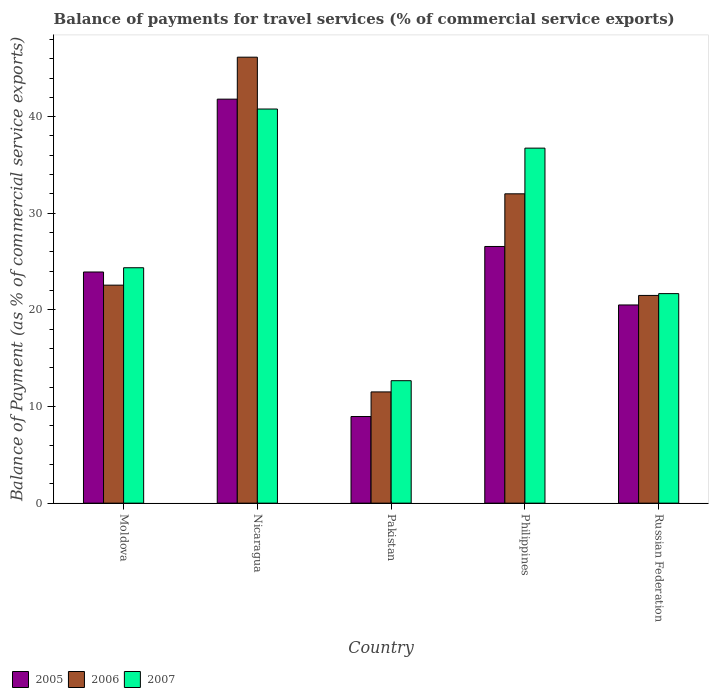How many different coloured bars are there?
Your answer should be compact. 3. How many groups of bars are there?
Make the answer very short. 5. Are the number of bars per tick equal to the number of legend labels?
Keep it short and to the point. Yes. Are the number of bars on each tick of the X-axis equal?
Give a very brief answer. Yes. How many bars are there on the 5th tick from the right?
Give a very brief answer. 3. What is the label of the 1st group of bars from the left?
Make the answer very short. Moldova. In how many cases, is the number of bars for a given country not equal to the number of legend labels?
Offer a very short reply. 0. What is the balance of payments for travel services in 2005 in Nicaragua?
Provide a short and direct response. 41.81. Across all countries, what is the maximum balance of payments for travel services in 2005?
Give a very brief answer. 41.81. Across all countries, what is the minimum balance of payments for travel services in 2007?
Your response must be concise. 12.67. In which country was the balance of payments for travel services in 2005 maximum?
Offer a terse response. Nicaragua. What is the total balance of payments for travel services in 2006 in the graph?
Offer a very short reply. 133.74. What is the difference between the balance of payments for travel services in 2005 in Moldova and that in Philippines?
Give a very brief answer. -2.64. What is the difference between the balance of payments for travel services in 2006 in Russian Federation and the balance of payments for travel services in 2005 in Moldova?
Provide a succinct answer. -2.43. What is the average balance of payments for travel services in 2005 per country?
Ensure brevity in your answer.  24.36. What is the difference between the balance of payments for travel services of/in 2005 and balance of payments for travel services of/in 2006 in Russian Federation?
Keep it short and to the point. -0.99. What is the ratio of the balance of payments for travel services in 2007 in Nicaragua to that in Philippines?
Give a very brief answer. 1.11. Is the balance of payments for travel services in 2006 in Nicaragua less than that in Pakistan?
Your response must be concise. No. Is the difference between the balance of payments for travel services in 2005 in Moldova and Pakistan greater than the difference between the balance of payments for travel services in 2006 in Moldova and Pakistan?
Provide a short and direct response. Yes. What is the difference between the highest and the second highest balance of payments for travel services in 2007?
Give a very brief answer. 16.43. What is the difference between the highest and the lowest balance of payments for travel services in 2005?
Offer a very short reply. 32.85. In how many countries, is the balance of payments for travel services in 2007 greater than the average balance of payments for travel services in 2007 taken over all countries?
Your answer should be compact. 2. Is the sum of the balance of payments for travel services in 2005 in Nicaragua and Russian Federation greater than the maximum balance of payments for travel services in 2006 across all countries?
Ensure brevity in your answer.  Yes. What does the 1st bar from the right in Russian Federation represents?
Offer a terse response. 2007. Is it the case that in every country, the sum of the balance of payments for travel services in 2007 and balance of payments for travel services in 2005 is greater than the balance of payments for travel services in 2006?
Give a very brief answer. Yes. How many countries are there in the graph?
Provide a short and direct response. 5. What is the difference between two consecutive major ticks on the Y-axis?
Ensure brevity in your answer.  10. Does the graph contain grids?
Give a very brief answer. No. What is the title of the graph?
Give a very brief answer. Balance of payments for travel services (% of commercial service exports). What is the label or title of the X-axis?
Ensure brevity in your answer.  Country. What is the label or title of the Y-axis?
Ensure brevity in your answer.  Balance of Payment (as % of commercial service exports). What is the Balance of Payment (as % of commercial service exports) in 2005 in Moldova?
Your answer should be very brief. 23.92. What is the Balance of Payment (as % of commercial service exports) in 2006 in Moldova?
Provide a short and direct response. 22.56. What is the Balance of Payment (as % of commercial service exports) in 2007 in Moldova?
Offer a terse response. 24.36. What is the Balance of Payment (as % of commercial service exports) in 2005 in Nicaragua?
Offer a very short reply. 41.81. What is the Balance of Payment (as % of commercial service exports) of 2006 in Nicaragua?
Your answer should be compact. 46.16. What is the Balance of Payment (as % of commercial service exports) in 2007 in Nicaragua?
Your answer should be very brief. 40.79. What is the Balance of Payment (as % of commercial service exports) in 2005 in Pakistan?
Your response must be concise. 8.97. What is the Balance of Payment (as % of commercial service exports) in 2006 in Pakistan?
Give a very brief answer. 11.51. What is the Balance of Payment (as % of commercial service exports) of 2007 in Pakistan?
Provide a short and direct response. 12.67. What is the Balance of Payment (as % of commercial service exports) in 2005 in Philippines?
Your response must be concise. 26.56. What is the Balance of Payment (as % of commercial service exports) of 2006 in Philippines?
Make the answer very short. 32.02. What is the Balance of Payment (as % of commercial service exports) in 2007 in Philippines?
Make the answer very short. 36.74. What is the Balance of Payment (as % of commercial service exports) of 2005 in Russian Federation?
Ensure brevity in your answer.  20.51. What is the Balance of Payment (as % of commercial service exports) in 2006 in Russian Federation?
Your answer should be very brief. 21.5. What is the Balance of Payment (as % of commercial service exports) in 2007 in Russian Federation?
Provide a short and direct response. 21.69. Across all countries, what is the maximum Balance of Payment (as % of commercial service exports) of 2005?
Give a very brief answer. 41.81. Across all countries, what is the maximum Balance of Payment (as % of commercial service exports) in 2006?
Ensure brevity in your answer.  46.16. Across all countries, what is the maximum Balance of Payment (as % of commercial service exports) of 2007?
Your answer should be very brief. 40.79. Across all countries, what is the minimum Balance of Payment (as % of commercial service exports) in 2005?
Your answer should be very brief. 8.97. Across all countries, what is the minimum Balance of Payment (as % of commercial service exports) in 2006?
Offer a very short reply. 11.51. Across all countries, what is the minimum Balance of Payment (as % of commercial service exports) in 2007?
Keep it short and to the point. 12.67. What is the total Balance of Payment (as % of commercial service exports) of 2005 in the graph?
Make the answer very short. 121.78. What is the total Balance of Payment (as % of commercial service exports) in 2006 in the graph?
Your answer should be compact. 133.74. What is the total Balance of Payment (as % of commercial service exports) in 2007 in the graph?
Make the answer very short. 136.26. What is the difference between the Balance of Payment (as % of commercial service exports) of 2005 in Moldova and that in Nicaragua?
Make the answer very short. -17.89. What is the difference between the Balance of Payment (as % of commercial service exports) in 2006 in Moldova and that in Nicaragua?
Your answer should be very brief. -23.59. What is the difference between the Balance of Payment (as % of commercial service exports) of 2007 in Moldova and that in Nicaragua?
Keep it short and to the point. -16.43. What is the difference between the Balance of Payment (as % of commercial service exports) of 2005 in Moldova and that in Pakistan?
Your answer should be very brief. 14.96. What is the difference between the Balance of Payment (as % of commercial service exports) in 2006 in Moldova and that in Pakistan?
Provide a succinct answer. 11.05. What is the difference between the Balance of Payment (as % of commercial service exports) of 2007 in Moldova and that in Pakistan?
Keep it short and to the point. 11.69. What is the difference between the Balance of Payment (as % of commercial service exports) in 2005 in Moldova and that in Philippines?
Your answer should be very brief. -2.64. What is the difference between the Balance of Payment (as % of commercial service exports) of 2006 in Moldova and that in Philippines?
Your answer should be very brief. -9.45. What is the difference between the Balance of Payment (as % of commercial service exports) of 2007 in Moldova and that in Philippines?
Provide a succinct answer. -12.38. What is the difference between the Balance of Payment (as % of commercial service exports) of 2005 in Moldova and that in Russian Federation?
Keep it short and to the point. 3.41. What is the difference between the Balance of Payment (as % of commercial service exports) of 2006 in Moldova and that in Russian Federation?
Make the answer very short. 1.06. What is the difference between the Balance of Payment (as % of commercial service exports) in 2007 in Moldova and that in Russian Federation?
Keep it short and to the point. 2.68. What is the difference between the Balance of Payment (as % of commercial service exports) in 2005 in Nicaragua and that in Pakistan?
Offer a terse response. 32.85. What is the difference between the Balance of Payment (as % of commercial service exports) in 2006 in Nicaragua and that in Pakistan?
Make the answer very short. 34.64. What is the difference between the Balance of Payment (as % of commercial service exports) in 2007 in Nicaragua and that in Pakistan?
Your answer should be very brief. 28.12. What is the difference between the Balance of Payment (as % of commercial service exports) in 2005 in Nicaragua and that in Philippines?
Offer a terse response. 15.25. What is the difference between the Balance of Payment (as % of commercial service exports) of 2006 in Nicaragua and that in Philippines?
Provide a short and direct response. 14.14. What is the difference between the Balance of Payment (as % of commercial service exports) of 2007 in Nicaragua and that in Philippines?
Ensure brevity in your answer.  4.05. What is the difference between the Balance of Payment (as % of commercial service exports) in 2005 in Nicaragua and that in Russian Federation?
Keep it short and to the point. 21.3. What is the difference between the Balance of Payment (as % of commercial service exports) in 2006 in Nicaragua and that in Russian Federation?
Ensure brevity in your answer.  24.66. What is the difference between the Balance of Payment (as % of commercial service exports) in 2007 in Nicaragua and that in Russian Federation?
Your answer should be compact. 19.1. What is the difference between the Balance of Payment (as % of commercial service exports) of 2005 in Pakistan and that in Philippines?
Keep it short and to the point. -17.6. What is the difference between the Balance of Payment (as % of commercial service exports) of 2006 in Pakistan and that in Philippines?
Provide a short and direct response. -20.5. What is the difference between the Balance of Payment (as % of commercial service exports) in 2007 in Pakistan and that in Philippines?
Keep it short and to the point. -24.07. What is the difference between the Balance of Payment (as % of commercial service exports) of 2005 in Pakistan and that in Russian Federation?
Offer a terse response. -11.55. What is the difference between the Balance of Payment (as % of commercial service exports) of 2006 in Pakistan and that in Russian Federation?
Your response must be concise. -9.98. What is the difference between the Balance of Payment (as % of commercial service exports) in 2007 in Pakistan and that in Russian Federation?
Your response must be concise. -9.01. What is the difference between the Balance of Payment (as % of commercial service exports) in 2005 in Philippines and that in Russian Federation?
Make the answer very short. 6.05. What is the difference between the Balance of Payment (as % of commercial service exports) in 2006 in Philippines and that in Russian Federation?
Keep it short and to the point. 10.52. What is the difference between the Balance of Payment (as % of commercial service exports) in 2007 in Philippines and that in Russian Federation?
Keep it short and to the point. 15.06. What is the difference between the Balance of Payment (as % of commercial service exports) in 2005 in Moldova and the Balance of Payment (as % of commercial service exports) in 2006 in Nicaragua?
Offer a terse response. -22.23. What is the difference between the Balance of Payment (as % of commercial service exports) in 2005 in Moldova and the Balance of Payment (as % of commercial service exports) in 2007 in Nicaragua?
Provide a succinct answer. -16.87. What is the difference between the Balance of Payment (as % of commercial service exports) in 2006 in Moldova and the Balance of Payment (as % of commercial service exports) in 2007 in Nicaragua?
Keep it short and to the point. -18.23. What is the difference between the Balance of Payment (as % of commercial service exports) in 2005 in Moldova and the Balance of Payment (as % of commercial service exports) in 2006 in Pakistan?
Offer a very short reply. 12.41. What is the difference between the Balance of Payment (as % of commercial service exports) in 2005 in Moldova and the Balance of Payment (as % of commercial service exports) in 2007 in Pakistan?
Your answer should be compact. 11.25. What is the difference between the Balance of Payment (as % of commercial service exports) of 2006 in Moldova and the Balance of Payment (as % of commercial service exports) of 2007 in Pakistan?
Your answer should be very brief. 9.89. What is the difference between the Balance of Payment (as % of commercial service exports) in 2005 in Moldova and the Balance of Payment (as % of commercial service exports) in 2006 in Philippines?
Your answer should be compact. -8.09. What is the difference between the Balance of Payment (as % of commercial service exports) of 2005 in Moldova and the Balance of Payment (as % of commercial service exports) of 2007 in Philippines?
Make the answer very short. -12.82. What is the difference between the Balance of Payment (as % of commercial service exports) in 2006 in Moldova and the Balance of Payment (as % of commercial service exports) in 2007 in Philippines?
Your response must be concise. -14.18. What is the difference between the Balance of Payment (as % of commercial service exports) in 2005 in Moldova and the Balance of Payment (as % of commercial service exports) in 2006 in Russian Federation?
Make the answer very short. 2.43. What is the difference between the Balance of Payment (as % of commercial service exports) in 2005 in Moldova and the Balance of Payment (as % of commercial service exports) in 2007 in Russian Federation?
Your answer should be compact. 2.24. What is the difference between the Balance of Payment (as % of commercial service exports) of 2006 in Moldova and the Balance of Payment (as % of commercial service exports) of 2007 in Russian Federation?
Give a very brief answer. 0.88. What is the difference between the Balance of Payment (as % of commercial service exports) in 2005 in Nicaragua and the Balance of Payment (as % of commercial service exports) in 2006 in Pakistan?
Your answer should be very brief. 30.3. What is the difference between the Balance of Payment (as % of commercial service exports) of 2005 in Nicaragua and the Balance of Payment (as % of commercial service exports) of 2007 in Pakistan?
Provide a succinct answer. 29.14. What is the difference between the Balance of Payment (as % of commercial service exports) of 2006 in Nicaragua and the Balance of Payment (as % of commercial service exports) of 2007 in Pakistan?
Ensure brevity in your answer.  33.48. What is the difference between the Balance of Payment (as % of commercial service exports) of 2005 in Nicaragua and the Balance of Payment (as % of commercial service exports) of 2006 in Philippines?
Your answer should be very brief. 9.8. What is the difference between the Balance of Payment (as % of commercial service exports) in 2005 in Nicaragua and the Balance of Payment (as % of commercial service exports) in 2007 in Philippines?
Provide a short and direct response. 5.07. What is the difference between the Balance of Payment (as % of commercial service exports) of 2006 in Nicaragua and the Balance of Payment (as % of commercial service exports) of 2007 in Philippines?
Make the answer very short. 9.41. What is the difference between the Balance of Payment (as % of commercial service exports) of 2005 in Nicaragua and the Balance of Payment (as % of commercial service exports) of 2006 in Russian Federation?
Keep it short and to the point. 20.31. What is the difference between the Balance of Payment (as % of commercial service exports) in 2005 in Nicaragua and the Balance of Payment (as % of commercial service exports) in 2007 in Russian Federation?
Your response must be concise. 20.13. What is the difference between the Balance of Payment (as % of commercial service exports) in 2006 in Nicaragua and the Balance of Payment (as % of commercial service exports) in 2007 in Russian Federation?
Keep it short and to the point. 24.47. What is the difference between the Balance of Payment (as % of commercial service exports) of 2005 in Pakistan and the Balance of Payment (as % of commercial service exports) of 2006 in Philippines?
Your answer should be compact. -23.05. What is the difference between the Balance of Payment (as % of commercial service exports) of 2005 in Pakistan and the Balance of Payment (as % of commercial service exports) of 2007 in Philippines?
Provide a succinct answer. -27.78. What is the difference between the Balance of Payment (as % of commercial service exports) of 2006 in Pakistan and the Balance of Payment (as % of commercial service exports) of 2007 in Philippines?
Your answer should be compact. -25.23. What is the difference between the Balance of Payment (as % of commercial service exports) of 2005 in Pakistan and the Balance of Payment (as % of commercial service exports) of 2006 in Russian Federation?
Make the answer very short. -12.53. What is the difference between the Balance of Payment (as % of commercial service exports) of 2005 in Pakistan and the Balance of Payment (as % of commercial service exports) of 2007 in Russian Federation?
Ensure brevity in your answer.  -12.72. What is the difference between the Balance of Payment (as % of commercial service exports) of 2006 in Pakistan and the Balance of Payment (as % of commercial service exports) of 2007 in Russian Federation?
Your response must be concise. -10.17. What is the difference between the Balance of Payment (as % of commercial service exports) in 2005 in Philippines and the Balance of Payment (as % of commercial service exports) in 2006 in Russian Federation?
Your answer should be very brief. 5.07. What is the difference between the Balance of Payment (as % of commercial service exports) in 2005 in Philippines and the Balance of Payment (as % of commercial service exports) in 2007 in Russian Federation?
Your answer should be very brief. 4.88. What is the difference between the Balance of Payment (as % of commercial service exports) in 2006 in Philippines and the Balance of Payment (as % of commercial service exports) in 2007 in Russian Federation?
Keep it short and to the point. 10.33. What is the average Balance of Payment (as % of commercial service exports) of 2005 per country?
Your response must be concise. 24.36. What is the average Balance of Payment (as % of commercial service exports) in 2006 per country?
Offer a terse response. 26.75. What is the average Balance of Payment (as % of commercial service exports) of 2007 per country?
Keep it short and to the point. 27.25. What is the difference between the Balance of Payment (as % of commercial service exports) in 2005 and Balance of Payment (as % of commercial service exports) in 2006 in Moldova?
Offer a very short reply. 1.36. What is the difference between the Balance of Payment (as % of commercial service exports) of 2005 and Balance of Payment (as % of commercial service exports) of 2007 in Moldova?
Your response must be concise. -0.44. What is the difference between the Balance of Payment (as % of commercial service exports) of 2006 and Balance of Payment (as % of commercial service exports) of 2007 in Moldova?
Your answer should be compact. -1.8. What is the difference between the Balance of Payment (as % of commercial service exports) of 2005 and Balance of Payment (as % of commercial service exports) of 2006 in Nicaragua?
Keep it short and to the point. -4.34. What is the difference between the Balance of Payment (as % of commercial service exports) of 2006 and Balance of Payment (as % of commercial service exports) of 2007 in Nicaragua?
Provide a succinct answer. 5.37. What is the difference between the Balance of Payment (as % of commercial service exports) of 2005 and Balance of Payment (as % of commercial service exports) of 2006 in Pakistan?
Provide a short and direct response. -2.55. What is the difference between the Balance of Payment (as % of commercial service exports) of 2005 and Balance of Payment (as % of commercial service exports) of 2007 in Pakistan?
Provide a succinct answer. -3.71. What is the difference between the Balance of Payment (as % of commercial service exports) in 2006 and Balance of Payment (as % of commercial service exports) in 2007 in Pakistan?
Give a very brief answer. -1.16. What is the difference between the Balance of Payment (as % of commercial service exports) of 2005 and Balance of Payment (as % of commercial service exports) of 2006 in Philippines?
Make the answer very short. -5.45. What is the difference between the Balance of Payment (as % of commercial service exports) of 2005 and Balance of Payment (as % of commercial service exports) of 2007 in Philippines?
Your answer should be very brief. -10.18. What is the difference between the Balance of Payment (as % of commercial service exports) in 2006 and Balance of Payment (as % of commercial service exports) in 2007 in Philippines?
Your answer should be compact. -4.73. What is the difference between the Balance of Payment (as % of commercial service exports) in 2005 and Balance of Payment (as % of commercial service exports) in 2006 in Russian Federation?
Keep it short and to the point. -0.99. What is the difference between the Balance of Payment (as % of commercial service exports) of 2005 and Balance of Payment (as % of commercial service exports) of 2007 in Russian Federation?
Provide a short and direct response. -1.17. What is the difference between the Balance of Payment (as % of commercial service exports) of 2006 and Balance of Payment (as % of commercial service exports) of 2007 in Russian Federation?
Keep it short and to the point. -0.19. What is the ratio of the Balance of Payment (as % of commercial service exports) in 2005 in Moldova to that in Nicaragua?
Offer a terse response. 0.57. What is the ratio of the Balance of Payment (as % of commercial service exports) in 2006 in Moldova to that in Nicaragua?
Your answer should be very brief. 0.49. What is the ratio of the Balance of Payment (as % of commercial service exports) in 2007 in Moldova to that in Nicaragua?
Ensure brevity in your answer.  0.6. What is the ratio of the Balance of Payment (as % of commercial service exports) in 2005 in Moldova to that in Pakistan?
Offer a terse response. 2.67. What is the ratio of the Balance of Payment (as % of commercial service exports) in 2006 in Moldova to that in Pakistan?
Provide a short and direct response. 1.96. What is the ratio of the Balance of Payment (as % of commercial service exports) of 2007 in Moldova to that in Pakistan?
Provide a short and direct response. 1.92. What is the ratio of the Balance of Payment (as % of commercial service exports) of 2005 in Moldova to that in Philippines?
Provide a short and direct response. 0.9. What is the ratio of the Balance of Payment (as % of commercial service exports) of 2006 in Moldova to that in Philippines?
Offer a very short reply. 0.7. What is the ratio of the Balance of Payment (as % of commercial service exports) in 2007 in Moldova to that in Philippines?
Offer a very short reply. 0.66. What is the ratio of the Balance of Payment (as % of commercial service exports) of 2005 in Moldova to that in Russian Federation?
Provide a succinct answer. 1.17. What is the ratio of the Balance of Payment (as % of commercial service exports) in 2006 in Moldova to that in Russian Federation?
Provide a short and direct response. 1.05. What is the ratio of the Balance of Payment (as % of commercial service exports) of 2007 in Moldova to that in Russian Federation?
Keep it short and to the point. 1.12. What is the ratio of the Balance of Payment (as % of commercial service exports) of 2005 in Nicaragua to that in Pakistan?
Ensure brevity in your answer.  4.66. What is the ratio of the Balance of Payment (as % of commercial service exports) of 2006 in Nicaragua to that in Pakistan?
Keep it short and to the point. 4.01. What is the ratio of the Balance of Payment (as % of commercial service exports) of 2007 in Nicaragua to that in Pakistan?
Ensure brevity in your answer.  3.22. What is the ratio of the Balance of Payment (as % of commercial service exports) in 2005 in Nicaragua to that in Philippines?
Make the answer very short. 1.57. What is the ratio of the Balance of Payment (as % of commercial service exports) of 2006 in Nicaragua to that in Philippines?
Offer a terse response. 1.44. What is the ratio of the Balance of Payment (as % of commercial service exports) in 2007 in Nicaragua to that in Philippines?
Offer a terse response. 1.11. What is the ratio of the Balance of Payment (as % of commercial service exports) in 2005 in Nicaragua to that in Russian Federation?
Ensure brevity in your answer.  2.04. What is the ratio of the Balance of Payment (as % of commercial service exports) of 2006 in Nicaragua to that in Russian Federation?
Your answer should be very brief. 2.15. What is the ratio of the Balance of Payment (as % of commercial service exports) of 2007 in Nicaragua to that in Russian Federation?
Provide a succinct answer. 1.88. What is the ratio of the Balance of Payment (as % of commercial service exports) in 2005 in Pakistan to that in Philippines?
Your answer should be compact. 0.34. What is the ratio of the Balance of Payment (as % of commercial service exports) of 2006 in Pakistan to that in Philippines?
Ensure brevity in your answer.  0.36. What is the ratio of the Balance of Payment (as % of commercial service exports) of 2007 in Pakistan to that in Philippines?
Offer a terse response. 0.34. What is the ratio of the Balance of Payment (as % of commercial service exports) in 2005 in Pakistan to that in Russian Federation?
Provide a short and direct response. 0.44. What is the ratio of the Balance of Payment (as % of commercial service exports) of 2006 in Pakistan to that in Russian Federation?
Offer a terse response. 0.54. What is the ratio of the Balance of Payment (as % of commercial service exports) in 2007 in Pakistan to that in Russian Federation?
Offer a terse response. 0.58. What is the ratio of the Balance of Payment (as % of commercial service exports) of 2005 in Philippines to that in Russian Federation?
Give a very brief answer. 1.3. What is the ratio of the Balance of Payment (as % of commercial service exports) of 2006 in Philippines to that in Russian Federation?
Provide a succinct answer. 1.49. What is the ratio of the Balance of Payment (as % of commercial service exports) in 2007 in Philippines to that in Russian Federation?
Give a very brief answer. 1.69. What is the difference between the highest and the second highest Balance of Payment (as % of commercial service exports) in 2005?
Keep it short and to the point. 15.25. What is the difference between the highest and the second highest Balance of Payment (as % of commercial service exports) of 2006?
Keep it short and to the point. 14.14. What is the difference between the highest and the second highest Balance of Payment (as % of commercial service exports) of 2007?
Your answer should be compact. 4.05. What is the difference between the highest and the lowest Balance of Payment (as % of commercial service exports) of 2005?
Keep it short and to the point. 32.85. What is the difference between the highest and the lowest Balance of Payment (as % of commercial service exports) of 2006?
Make the answer very short. 34.64. What is the difference between the highest and the lowest Balance of Payment (as % of commercial service exports) of 2007?
Provide a succinct answer. 28.12. 